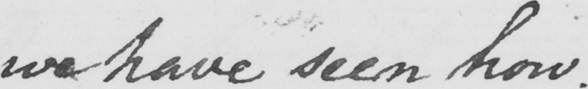What does this handwritten line say? we have seen how . 